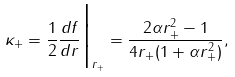<formula> <loc_0><loc_0><loc_500><loc_500>\kappa _ { + } = \frac { 1 } { 2 } \frac { d f } { d r } \Big | _ { r _ { + } } = \frac { 2 \alpha r _ { + } ^ { 2 } - 1 } { 4 r _ { + } ( 1 + \alpha r _ { + } ^ { 2 } ) } ,</formula> 